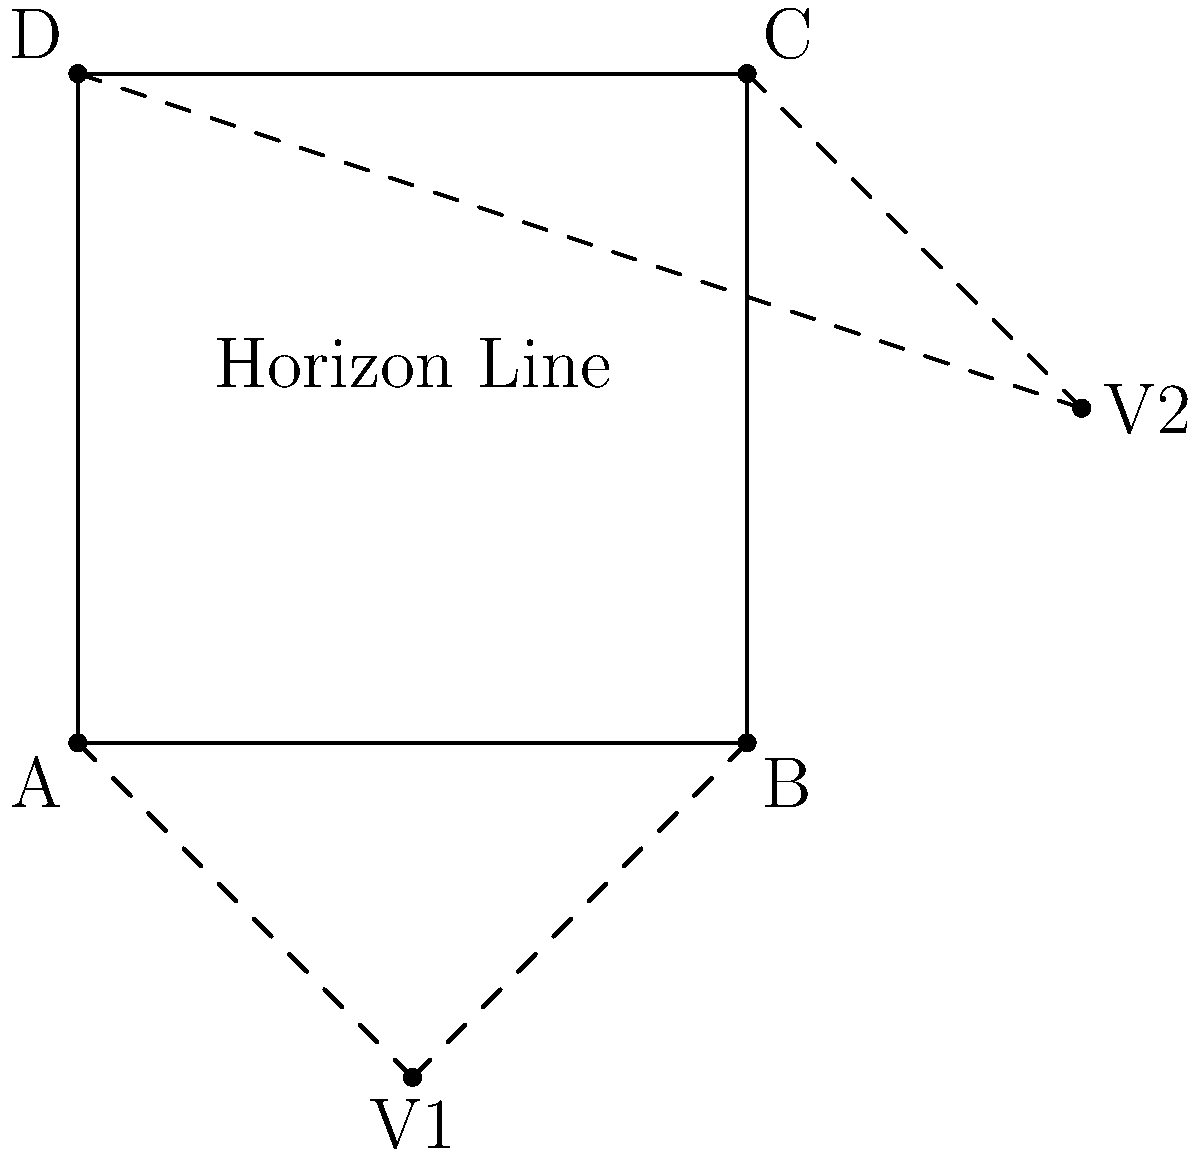In a Japanese landscape painting utilizing two-point perspective, how many vanishing points are typically used, and where are they generally positioned in relation to the horizon line? To answer this question, let's break down the key elements of two-point perspective in Japanese landscape painting:

1. Two-point perspective uses two vanishing points to create depth and dimension in a scene.

2. In the diagram, we can see two vanishing points: V1 and V2.

3. The horizon line is represented in the middle of the image, running horizontally.

4. Notice that both vanishing points (V1 and V2) are positioned on the horizon line.

5. V1 is located to the left of the picture plane, while V2 is to the right.

6. This arrangement allows for the creation of depth and three-dimensionality in the painting, as all parallel lines in the scene will converge towards one of these two points.

7. In traditional Japanese landscape painting, this technique would be subtly employed to create a sense of space and distance, often in conjunction with other techniques like atmospheric perspective.

Therefore, in a Japanese landscape painting using two-point perspective, two vanishing points are typically used, and they are generally positioned on the horizon line, one on each side of the picture plane.
Answer: Two vanishing points, positioned on the horizon line 